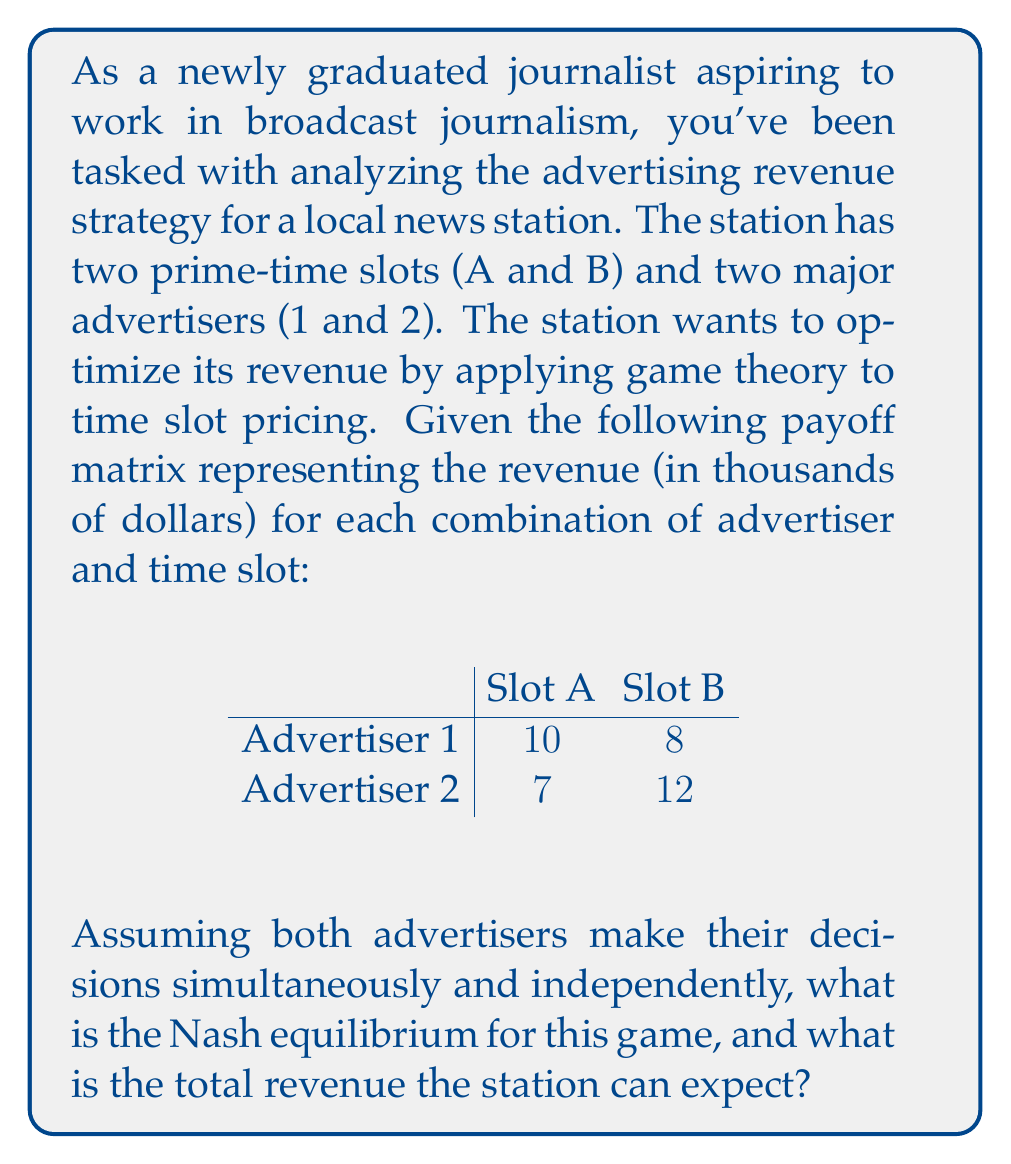What is the answer to this math problem? To solve this problem, we need to follow these steps:

1. Identify the strategies for each player (advertiser).
2. Determine the best response for each player given the other player's strategy.
3. Find the Nash equilibrium, where neither player has an incentive to change their strategy.
4. Calculate the total revenue for the station based on the Nash equilibrium.

Step 1: Strategies
- Advertiser 1's strategies: Choose Slot A or Slot B
- Advertiser 2's strategies: Choose Slot A or Slot B

Step 2: Best responses
For Advertiser 1:
- If Advertiser 2 chooses Slot A, Advertiser 1's best response is Slot A (10 > 8)
- If Advertiser 2 chooses Slot B, Advertiser 1's best response is Slot A (10 > 8)

For Advertiser 2:
- If Advertiser 1 chooses Slot A, Advertiser 2's best response is Slot B (12 > 7)
- If Advertiser 1 chooses Slot B, Advertiser 2's best response is Slot B (12 > 7)

Step 3: Nash equilibrium
The Nash equilibrium occurs when Advertiser 1 chooses Slot A and Advertiser 2 chooses Slot B. This is because:
- Given Advertiser 2's choice of Slot B, Advertiser 1's best response is Slot A
- Given Advertiser 1's choice of Slot A, Advertiser 2's best response is Slot B

Neither advertiser has an incentive to change their strategy unilaterally.

Step 4: Total revenue
The total revenue for the station is the sum of the payoffs for the Nash equilibrium strategy:
Total Revenue = Payoff(Advertiser 1, Slot A) + Payoff(Advertiser 2, Slot B)
               = $10,000 + $12,000
               = $22,000
Answer: The Nash equilibrium is (Slot A, Slot B) for (Advertiser 1, Advertiser 2), and the total revenue the station can expect is $22,000. 